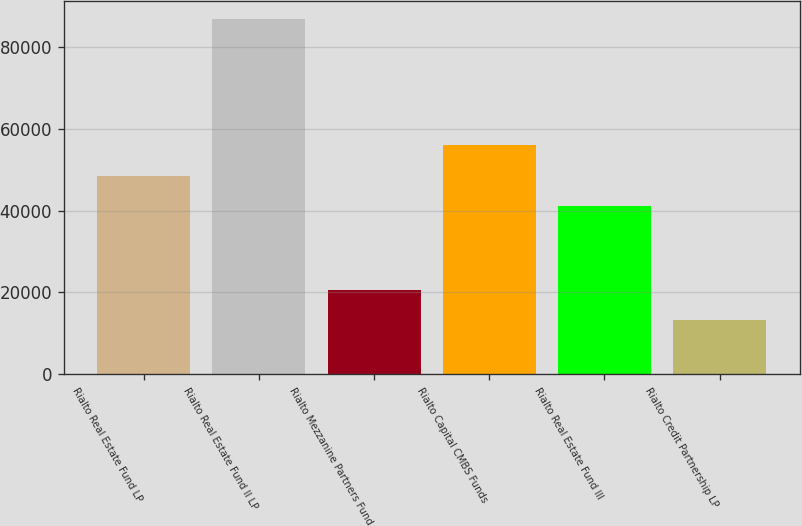Convert chart to OTSL. <chart><loc_0><loc_0><loc_500><loc_500><bar_chart><fcel>Rialto Real Estate Fund LP<fcel>Rialto Real Estate Fund II LP<fcel>Rialto Mezzanine Partners Fund<fcel>Rialto Capital CMBS Funds<fcel>Rialto Real Estate Fund III<fcel>Rialto Credit Partnership LP<nl><fcel>48584.6<fcel>86904<fcel>20649.6<fcel>55946.2<fcel>41223<fcel>13288<nl></chart> 